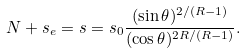Convert formula to latex. <formula><loc_0><loc_0><loc_500><loc_500>N + s _ { e } = s = s _ { 0 } \frac { ( \sin \theta ) ^ { 2 / ( R - 1 ) } } { ( \cos \theta ) ^ { 2 R / ( R - 1 ) } } .</formula> 